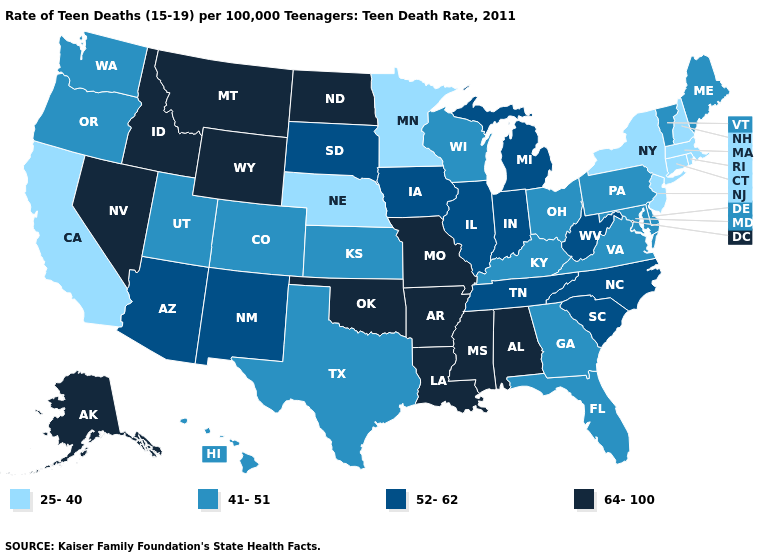Among the states that border Wisconsin , does Minnesota have the highest value?
Answer briefly. No. Does Kansas have a lower value than Tennessee?
Give a very brief answer. Yes. Does Michigan have the highest value in the MidWest?
Concise answer only. No. Name the states that have a value in the range 52-62?
Write a very short answer. Arizona, Illinois, Indiana, Iowa, Michigan, New Mexico, North Carolina, South Carolina, South Dakota, Tennessee, West Virginia. Does the map have missing data?
Keep it brief. No. Name the states that have a value in the range 52-62?
Concise answer only. Arizona, Illinois, Indiana, Iowa, Michigan, New Mexico, North Carolina, South Carolina, South Dakota, Tennessee, West Virginia. Name the states that have a value in the range 64-100?
Be succinct. Alabama, Alaska, Arkansas, Idaho, Louisiana, Mississippi, Missouri, Montana, Nevada, North Dakota, Oklahoma, Wyoming. What is the value of North Dakota?
Short answer required. 64-100. Does Oregon have a lower value than Indiana?
Quick response, please. Yes. Does Wisconsin have a lower value than Michigan?
Keep it brief. Yes. Among the states that border Montana , which have the lowest value?
Give a very brief answer. South Dakota. What is the value of Iowa?
Answer briefly. 52-62. Name the states that have a value in the range 52-62?
Keep it brief. Arizona, Illinois, Indiana, Iowa, Michigan, New Mexico, North Carolina, South Carolina, South Dakota, Tennessee, West Virginia. What is the value of Iowa?
Be succinct. 52-62. 